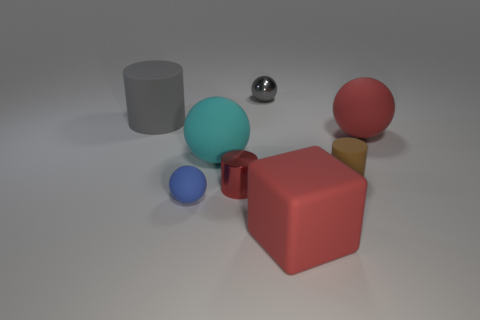Subtract all small gray metallic balls. How many balls are left? 3 Subtract 1 blocks. How many blocks are left? 0 Subtract all red cylinders. Subtract all purple blocks. How many cylinders are left? 2 Subtract all cyan cylinders. How many blue spheres are left? 1 Subtract all matte objects. Subtract all big yellow metal spheres. How many objects are left? 2 Add 6 big things. How many big things are left? 10 Add 7 gray rubber objects. How many gray rubber objects exist? 8 Add 2 large red things. How many objects exist? 10 Subtract all cyan balls. How many balls are left? 3 Subtract 0 purple blocks. How many objects are left? 8 